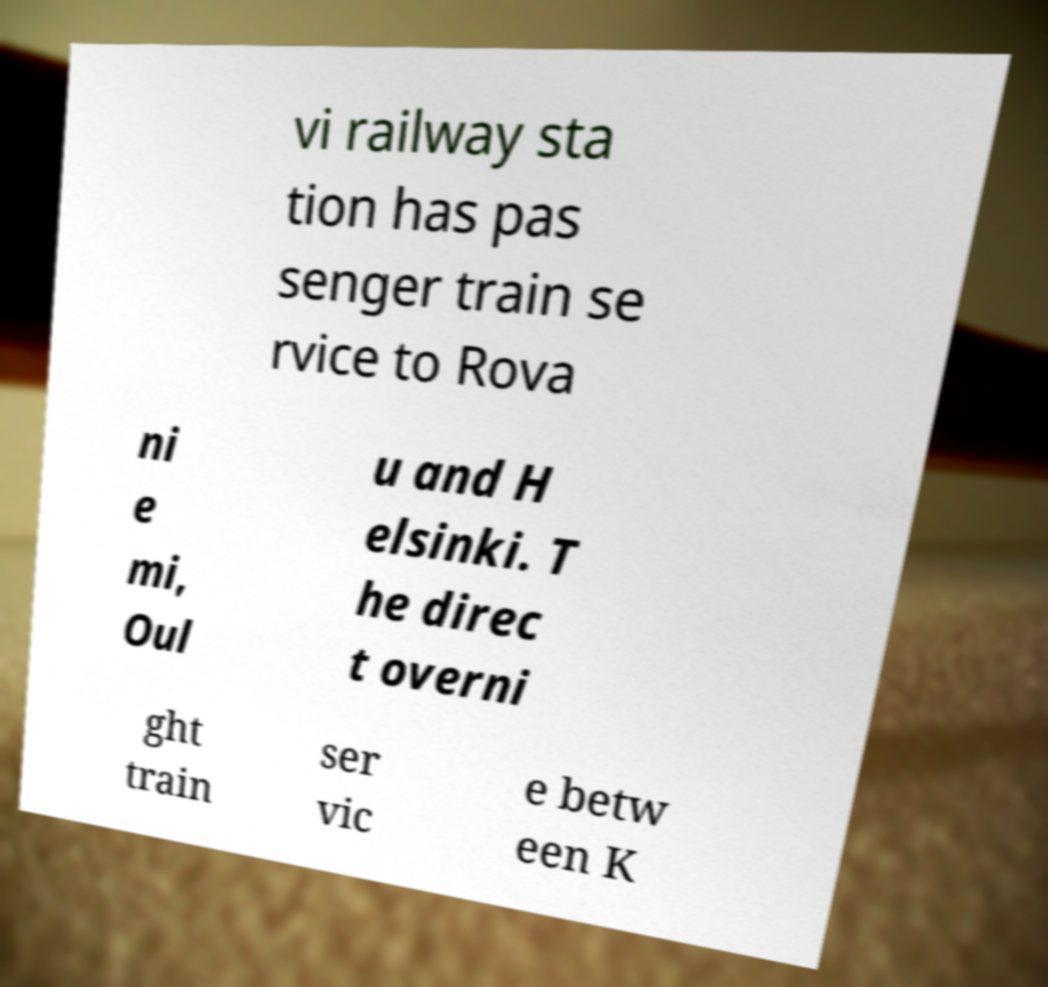For documentation purposes, I need the text within this image transcribed. Could you provide that? vi railway sta tion has pas senger train se rvice to Rova ni e mi, Oul u and H elsinki. T he direc t overni ght train ser vic e betw een K 